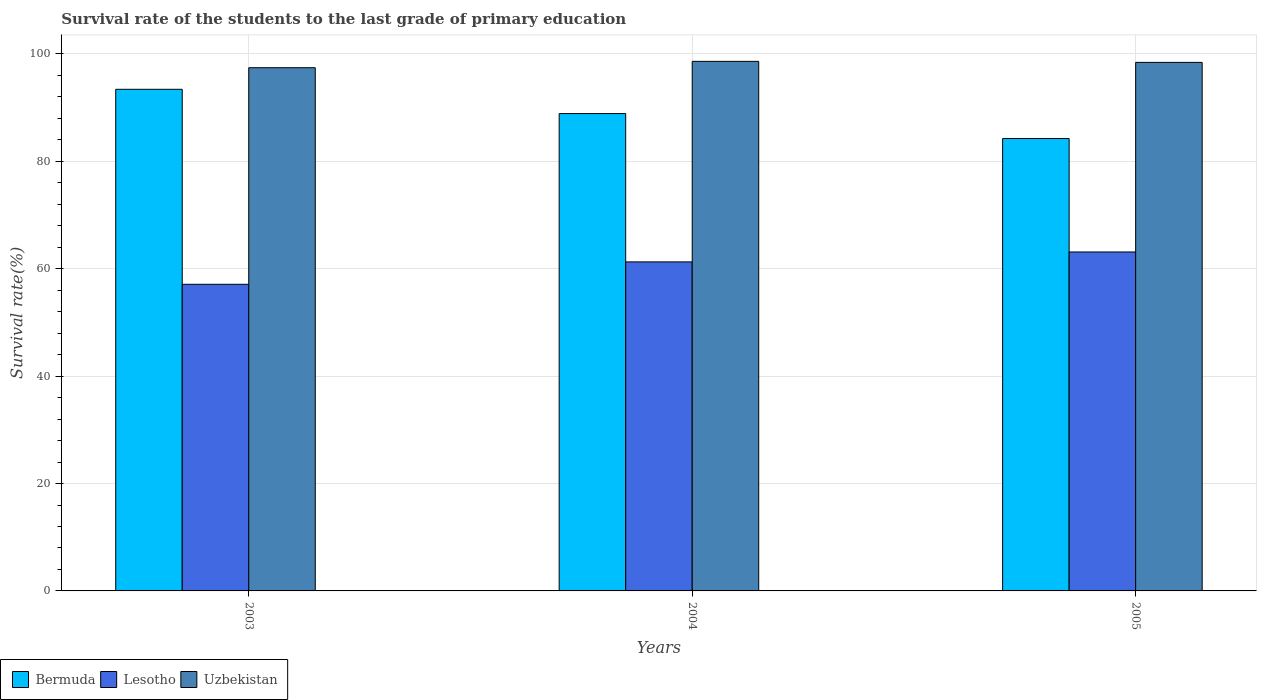How many different coloured bars are there?
Give a very brief answer. 3. How many groups of bars are there?
Make the answer very short. 3. How many bars are there on the 2nd tick from the left?
Your response must be concise. 3. What is the survival rate of the students in Bermuda in 2005?
Provide a short and direct response. 84.24. Across all years, what is the maximum survival rate of the students in Bermuda?
Your answer should be compact. 93.41. Across all years, what is the minimum survival rate of the students in Bermuda?
Offer a terse response. 84.24. In which year was the survival rate of the students in Bermuda minimum?
Make the answer very short. 2005. What is the total survival rate of the students in Uzbekistan in the graph?
Your answer should be very brief. 294.47. What is the difference between the survival rate of the students in Uzbekistan in 2004 and that in 2005?
Provide a succinct answer. 0.19. What is the difference between the survival rate of the students in Uzbekistan in 2003 and the survival rate of the students in Bermuda in 2004?
Provide a short and direct response. 8.54. What is the average survival rate of the students in Bermuda per year?
Provide a succinct answer. 88.85. In the year 2005, what is the difference between the survival rate of the students in Uzbekistan and survival rate of the students in Bermuda?
Offer a very short reply. 14.18. What is the ratio of the survival rate of the students in Bermuda in 2004 to that in 2005?
Ensure brevity in your answer.  1.06. Is the survival rate of the students in Uzbekistan in 2003 less than that in 2004?
Your answer should be compact. Yes. What is the difference between the highest and the second highest survival rate of the students in Lesotho?
Give a very brief answer. 1.85. What is the difference between the highest and the lowest survival rate of the students in Bermuda?
Provide a succinct answer. 9.17. In how many years, is the survival rate of the students in Lesotho greater than the average survival rate of the students in Lesotho taken over all years?
Provide a short and direct response. 2. Is the sum of the survival rate of the students in Bermuda in 2003 and 2004 greater than the maximum survival rate of the students in Lesotho across all years?
Your answer should be very brief. Yes. What does the 1st bar from the left in 2003 represents?
Your answer should be compact. Bermuda. What does the 2nd bar from the right in 2003 represents?
Keep it short and to the point. Lesotho. How many bars are there?
Keep it short and to the point. 9. Are all the bars in the graph horizontal?
Your answer should be compact. No. Are the values on the major ticks of Y-axis written in scientific E-notation?
Provide a succinct answer. No. Does the graph contain any zero values?
Ensure brevity in your answer.  No. Where does the legend appear in the graph?
Provide a succinct answer. Bottom left. How many legend labels are there?
Provide a short and direct response. 3. What is the title of the graph?
Offer a terse response. Survival rate of the students to the last grade of primary education. Does "Upper middle income" appear as one of the legend labels in the graph?
Make the answer very short. No. What is the label or title of the Y-axis?
Your answer should be compact. Survival rate(%). What is the Survival rate(%) of Bermuda in 2003?
Your response must be concise. 93.41. What is the Survival rate(%) of Lesotho in 2003?
Your response must be concise. 57.1. What is the Survival rate(%) of Uzbekistan in 2003?
Your answer should be very brief. 97.43. What is the Survival rate(%) in Bermuda in 2004?
Offer a terse response. 88.89. What is the Survival rate(%) of Lesotho in 2004?
Ensure brevity in your answer.  61.27. What is the Survival rate(%) of Uzbekistan in 2004?
Your response must be concise. 98.62. What is the Survival rate(%) in Bermuda in 2005?
Provide a short and direct response. 84.24. What is the Survival rate(%) in Lesotho in 2005?
Your response must be concise. 63.12. What is the Survival rate(%) of Uzbekistan in 2005?
Offer a terse response. 98.42. Across all years, what is the maximum Survival rate(%) of Bermuda?
Ensure brevity in your answer.  93.41. Across all years, what is the maximum Survival rate(%) in Lesotho?
Your answer should be very brief. 63.12. Across all years, what is the maximum Survival rate(%) in Uzbekistan?
Make the answer very short. 98.62. Across all years, what is the minimum Survival rate(%) of Bermuda?
Make the answer very short. 84.24. Across all years, what is the minimum Survival rate(%) of Lesotho?
Make the answer very short. 57.1. Across all years, what is the minimum Survival rate(%) in Uzbekistan?
Offer a terse response. 97.43. What is the total Survival rate(%) in Bermuda in the graph?
Ensure brevity in your answer.  266.54. What is the total Survival rate(%) in Lesotho in the graph?
Offer a terse response. 181.49. What is the total Survival rate(%) in Uzbekistan in the graph?
Ensure brevity in your answer.  294.47. What is the difference between the Survival rate(%) in Bermuda in 2003 and that in 2004?
Provide a short and direct response. 4.52. What is the difference between the Survival rate(%) in Lesotho in 2003 and that in 2004?
Give a very brief answer. -4.17. What is the difference between the Survival rate(%) of Uzbekistan in 2003 and that in 2004?
Your answer should be very brief. -1.18. What is the difference between the Survival rate(%) in Bermuda in 2003 and that in 2005?
Offer a terse response. 9.17. What is the difference between the Survival rate(%) of Lesotho in 2003 and that in 2005?
Your answer should be compact. -6.02. What is the difference between the Survival rate(%) of Uzbekistan in 2003 and that in 2005?
Make the answer very short. -0.99. What is the difference between the Survival rate(%) of Bermuda in 2004 and that in 2005?
Your answer should be compact. 4.65. What is the difference between the Survival rate(%) in Lesotho in 2004 and that in 2005?
Your response must be concise. -1.85. What is the difference between the Survival rate(%) in Uzbekistan in 2004 and that in 2005?
Offer a terse response. 0.19. What is the difference between the Survival rate(%) of Bermuda in 2003 and the Survival rate(%) of Lesotho in 2004?
Make the answer very short. 32.14. What is the difference between the Survival rate(%) in Bermuda in 2003 and the Survival rate(%) in Uzbekistan in 2004?
Your answer should be very brief. -5.2. What is the difference between the Survival rate(%) in Lesotho in 2003 and the Survival rate(%) in Uzbekistan in 2004?
Offer a terse response. -41.52. What is the difference between the Survival rate(%) of Bermuda in 2003 and the Survival rate(%) of Lesotho in 2005?
Ensure brevity in your answer.  30.29. What is the difference between the Survival rate(%) of Bermuda in 2003 and the Survival rate(%) of Uzbekistan in 2005?
Offer a very short reply. -5.01. What is the difference between the Survival rate(%) in Lesotho in 2003 and the Survival rate(%) in Uzbekistan in 2005?
Your answer should be compact. -41.33. What is the difference between the Survival rate(%) in Bermuda in 2004 and the Survival rate(%) in Lesotho in 2005?
Offer a terse response. 25.77. What is the difference between the Survival rate(%) of Bermuda in 2004 and the Survival rate(%) of Uzbekistan in 2005?
Your answer should be very brief. -9.53. What is the difference between the Survival rate(%) in Lesotho in 2004 and the Survival rate(%) in Uzbekistan in 2005?
Give a very brief answer. -37.15. What is the average Survival rate(%) in Bermuda per year?
Your answer should be very brief. 88.85. What is the average Survival rate(%) in Lesotho per year?
Offer a terse response. 60.5. What is the average Survival rate(%) of Uzbekistan per year?
Provide a succinct answer. 98.16. In the year 2003, what is the difference between the Survival rate(%) in Bermuda and Survival rate(%) in Lesotho?
Ensure brevity in your answer.  36.31. In the year 2003, what is the difference between the Survival rate(%) in Bermuda and Survival rate(%) in Uzbekistan?
Your answer should be compact. -4.02. In the year 2003, what is the difference between the Survival rate(%) in Lesotho and Survival rate(%) in Uzbekistan?
Offer a very short reply. -40.33. In the year 2004, what is the difference between the Survival rate(%) of Bermuda and Survival rate(%) of Lesotho?
Keep it short and to the point. 27.62. In the year 2004, what is the difference between the Survival rate(%) of Bermuda and Survival rate(%) of Uzbekistan?
Your answer should be compact. -9.72. In the year 2004, what is the difference between the Survival rate(%) of Lesotho and Survival rate(%) of Uzbekistan?
Offer a very short reply. -37.34. In the year 2005, what is the difference between the Survival rate(%) of Bermuda and Survival rate(%) of Lesotho?
Your response must be concise. 21.12. In the year 2005, what is the difference between the Survival rate(%) of Bermuda and Survival rate(%) of Uzbekistan?
Your answer should be very brief. -14.18. In the year 2005, what is the difference between the Survival rate(%) in Lesotho and Survival rate(%) in Uzbekistan?
Offer a very short reply. -35.31. What is the ratio of the Survival rate(%) in Bermuda in 2003 to that in 2004?
Offer a terse response. 1.05. What is the ratio of the Survival rate(%) in Lesotho in 2003 to that in 2004?
Your answer should be very brief. 0.93. What is the ratio of the Survival rate(%) of Uzbekistan in 2003 to that in 2004?
Provide a succinct answer. 0.99. What is the ratio of the Survival rate(%) of Bermuda in 2003 to that in 2005?
Ensure brevity in your answer.  1.11. What is the ratio of the Survival rate(%) of Lesotho in 2003 to that in 2005?
Ensure brevity in your answer.  0.9. What is the ratio of the Survival rate(%) of Bermuda in 2004 to that in 2005?
Give a very brief answer. 1.06. What is the ratio of the Survival rate(%) in Lesotho in 2004 to that in 2005?
Ensure brevity in your answer.  0.97. What is the ratio of the Survival rate(%) of Uzbekistan in 2004 to that in 2005?
Provide a succinct answer. 1. What is the difference between the highest and the second highest Survival rate(%) of Bermuda?
Make the answer very short. 4.52. What is the difference between the highest and the second highest Survival rate(%) in Lesotho?
Provide a succinct answer. 1.85. What is the difference between the highest and the second highest Survival rate(%) of Uzbekistan?
Provide a short and direct response. 0.19. What is the difference between the highest and the lowest Survival rate(%) in Bermuda?
Offer a terse response. 9.17. What is the difference between the highest and the lowest Survival rate(%) in Lesotho?
Your answer should be compact. 6.02. What is the difference between the highest and the lowest Survival rate(%) of Uzbekistan?
Make the answer very short. 1.18. 